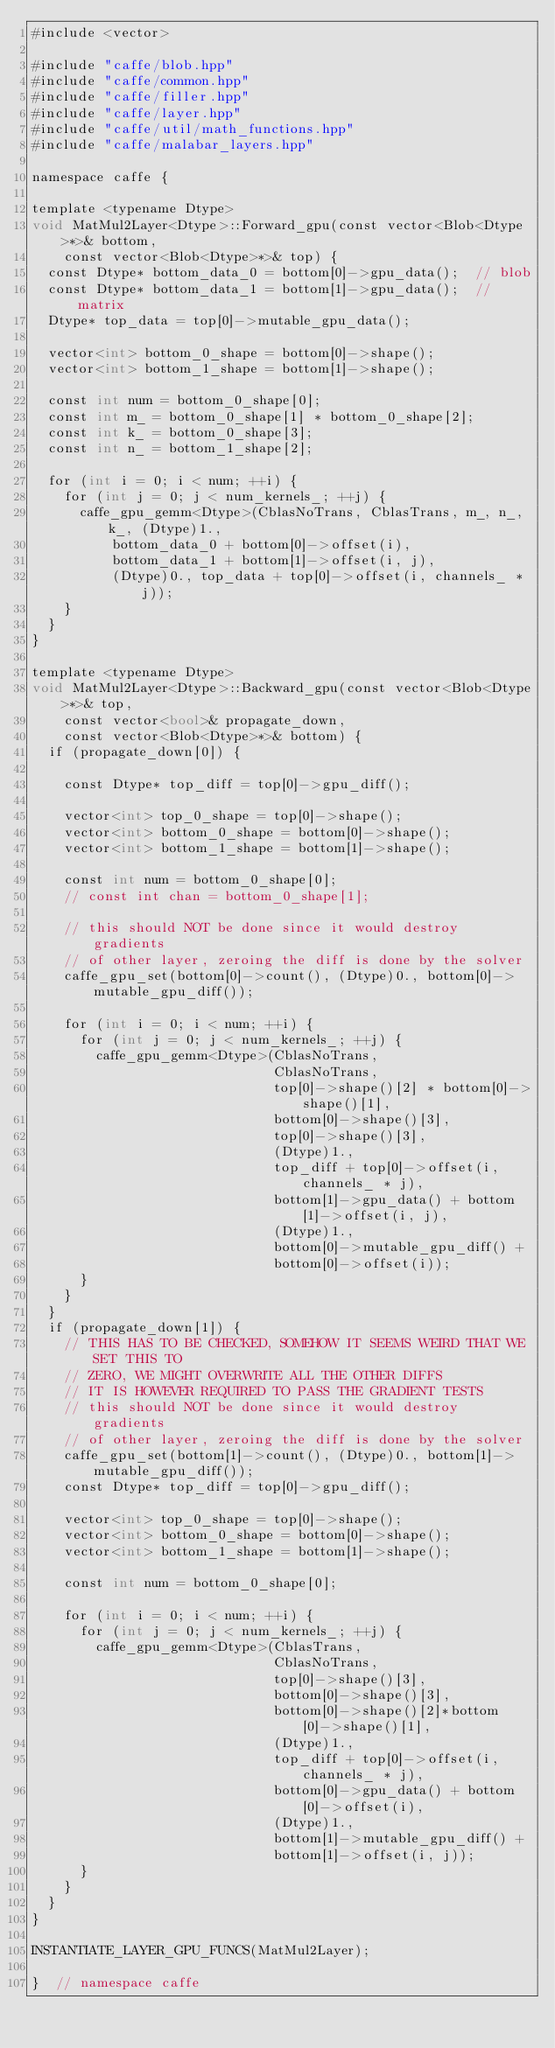Convert code to text. <code><loc_0><loc_0><loc_500><loc_500><_Cuda_>#include <vector>

#include "caffe/blob.hpp"
#include "caffe/common.hpp"
#include "caffe/filler.hpp"
#include "caffe/layer.hpp"
#include "caffe/util/math_functions.hpp"
#include "caffe/malabar_layers.hpp"

namespace caffe {

template <typename Dtype>
void MatMul2Layer<Dtype>::Forward_gpu(const vector<Blob<Dtype>*>& bottom,
    const vector<Blob<Dtype>*>& top) {
  const Dtype* bottom_data_0 = bottom[0]->gpu_data();  // blob
  const Dtype* bottom_data_1 = bottom[1]->gpu_data();  // matrix
  Dtype* top_data = top[0]->mutable_gpu_data();

  vector<int> bottom_0_shape = bottom[0]->shape();
  vector<int> bottom_1_shape = bottom[1]->shape();

  const int num = bottom_0_shape[0];
  const int m_ = bottom_0_shape[1] * bottom_0_shape[2];
  const int k_ = bottom_0_shape[3];
  const int n_ = bottom_1_shape[2];

  for (int i = 0; i < num; ++i) {
    for (int j = 0; j < num_kernels_; ++j) {
      caffe_gpu_gemm<Dtype>(CblasNoTrans, CblasTrans, m_, n_, k_, (Dtype)1.,
          bottom_data_0 + bottom[0]->offset(i),
          bottom_data_1 + bottom[1]->offset(i, j),
          (Dtype)0., top_data + top[0]->offset(i, channels_ * j));
    }
  }
}

template <typename Dtype>
void MatMul2Layer<Dtype>::Backward_gpu(const vector<Blob<Dtype>*>& top,
    const vector<bool>& propagate_down,
    const vector<Blob<Dtype>*>& bottom) {
  if (propagate_down[0]) {

    const Dtype* top_diff = top[0]->gpu_diff();

    vector<int> top_0_shape = top[0]->shape();
    vector<int> bottom_0_shape = bottom[0]->shape();
    vector<int> bottom_1_shape = bottom[1]->shape();

    const int num = bottom_0_shape[0];
    // const int chan = bottom_0_shape[1];

    // this should NOT be done since it would destroy gradients
    // of other layer, zeroing the diff is done by the solver
    caffe_gpu_set(bottom[0]->count(), (Dtype)0., bottom[0]->mutable_gpu_diff());

    for (int i = 0; i < num; ++i) {
      for (int j = 0; j < num_kernels_; ++j) {
        caffe_gpu_gemm<Dtype>(CblasNoTrans,
                              CblasNoTrans,
                              top[0]->shape()[2] * bottom[0]->shape()[1],
                              bottom[0]->shape()[3],
                              top[0]->shape()[3],
                              (Dtype)1.,
                              top_diff + top[0]->offset(i, channels_ * j),
                              bottom[1]->gpu_data() + bottom[1]->offset(i, j),
                              (Dtype)1.,
                              bottom[0]->mutable_gpu_diff() +
                              bottom[0]->offset(i));
      }
    }
  }
  if (propagate_down[1]) {
    // THIS HAS TO BE CHECKED, SOMEHOW IT SEEMS WEIRD THAT WE SET THIS TO
    // ZERO, WE MIGHT OVERWRITE ALL THE OTHER DIFFS
    // IT IS HOWEVER REQUIRED TO PASS THE GRADIENT TESTS
    // this should NOT be done since it would destroy gradients
    // of other layer, zeroing the diff is done by the solver
    caffe_gpu_set(bottom[1]->count(), (Dtype)0., bottom[1]->mutable_gpu_diff());
    const Dtype* top_diff = top[0]->gpu_diff();

    vector<int> top_0_shape = top[0]->shape();
    vector<int> bottom_0_shape = bottom[0]->shape();
    vector<int> bottom_1_shape = bottom[1]->shape();

    const int num = bottom_0_shape[0];

    for (int i = 0; i < num; ++i) {
      for (int j = 0; j < num_kernels_; ++j) {
        caffe_gpu_gemm<Dtype>(CblasTrans,
                              CblasNoTrans,
                              top[0]->shape()[3],
                              bottom[0]->shape()[3],
                              bottom[0]->shape()[2]*bottom[0]->shape()[1],
                              (Dtype)1.,
                              top_diff + top[0]->offset(i, channels_ * j),
                              bottom[0]->gpu_data() + bottom[0]->offset(i),
                              (Dtype)1.,
                              bottom[1]->mutable_gpu_diff() +
                              bottom[1]->offset(i, j));
      }
    }
  }
}

INSTANTIATE_LAYER_GPU_FUNCS(MatMul2Layer);

}  // namespace caffe
</code> 